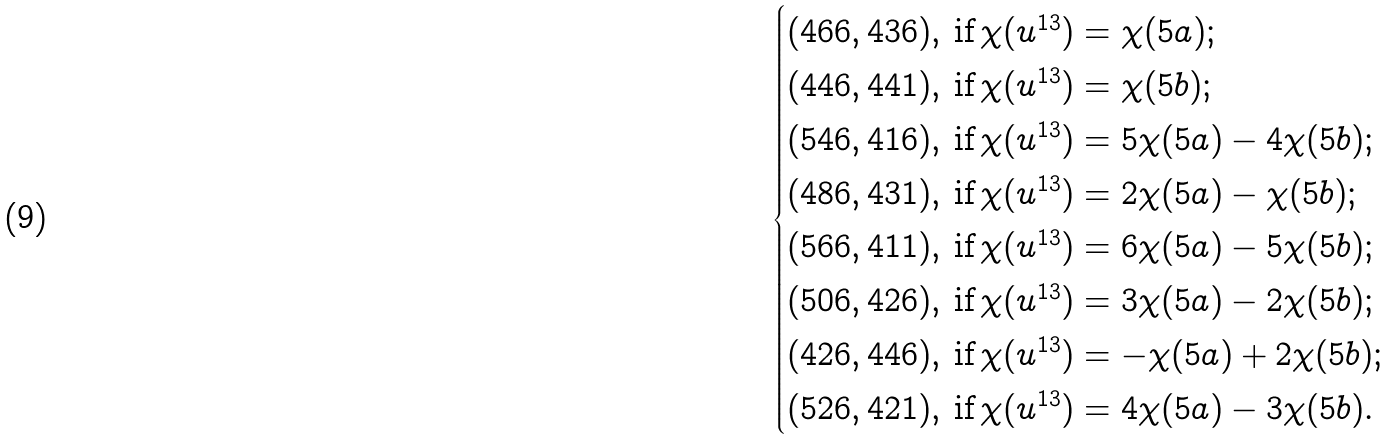<formula> <loc_0><loc_0><loc_500><loc_500>\begin{cases} ( 4 6 6 , 4 3 6 ) , \, \text {if} \, \chi ( u ^ { 1 3 } ) = \chi ( 5 a ) ; \\ ( 4 4 6 , 4 4 1 ) , \, \text {if} \, \chi ( u ^ { 1 3 } ) = \chi ( 5 b ) ; \\ ( 5 4 6 , 4 1 6 ) , \, \text {if} \, \chi ( u ^ { 1 3 } ) = 5 \chi ( 5 a ) - 4 \chi ( 5 b ) ; \\ ( 4 8 6 , 4 3 1 ) , \, \text {if} \, \chi ( u ^ { 1 3 } ) = 2 \chi ( 5 a ) - \chi ( 5 b ) ; \\ ( 5 6 6 , 4 1 1 ) , \, \text {if} \, \chi ( u ^ { 1 3 } ) = 6 \chi ( 5 a ) - 5 \chi ( 5 b ) ; \\ ( 5 0 6 , 4 2 6 ) , \, \text {if} \, \chi ( u ^ { 1 3 } ) = 3 \chi ( 5 a ) - 2 \chi ( 5 b ) ; \\ ( 4 2 6 , 4 4 6 ) , \, \text {if} \, \chi ( u ^ { 1 3 } ) = - \chi ( 5 a ) + 2 \chi ( 5 b ) ; \\ ( 5 2 6 , 4 2 1 ) , \, \text {if} \, \chi ( u ^ { 1 3 } ) = 4 \chi ( 5 a ) - 3 \chi ( 5 b ) . \end{cases}</formula> 